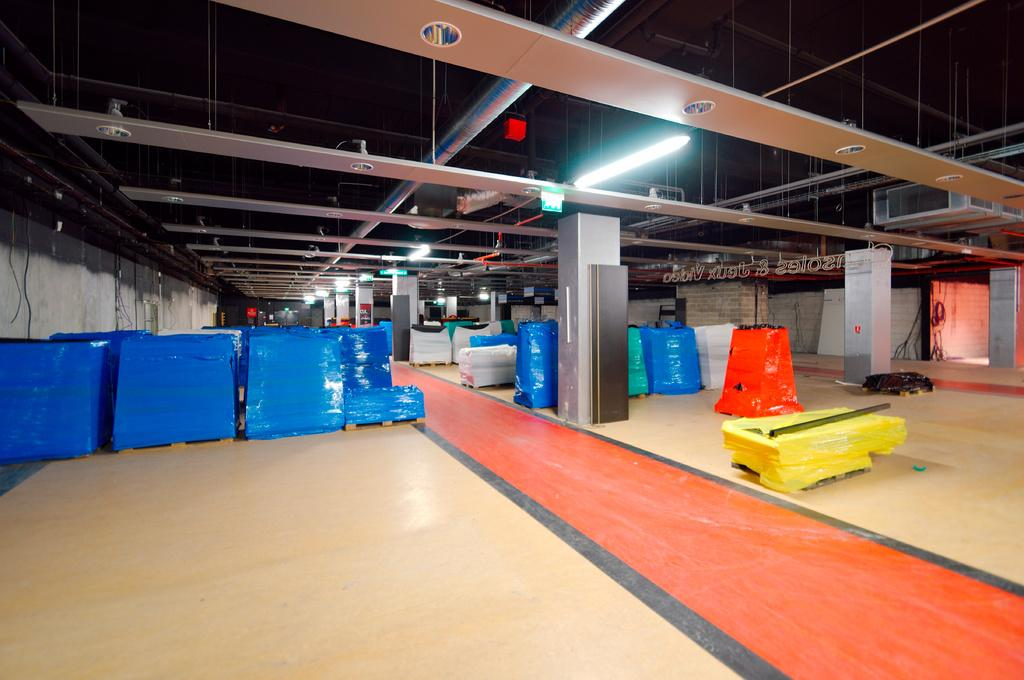What objects can be seen in the image? There are blocks, covers, lights, and pipes in the image. What type of structure is visible in the image? There is a roof visible in the image, which suggests a building or room. What is at the top of the image? There are lights at the top of the image. What is at the bottom of the image? There is a floor at the bottom of the image. What can be seen in the background of the image? There is a wall in the background of the image. What type of vegetable is growing on the wall in the image? There are no vegetables present in the image; it only features blocks, covers, lights, pipes, a roof, a floor, and a wall. 